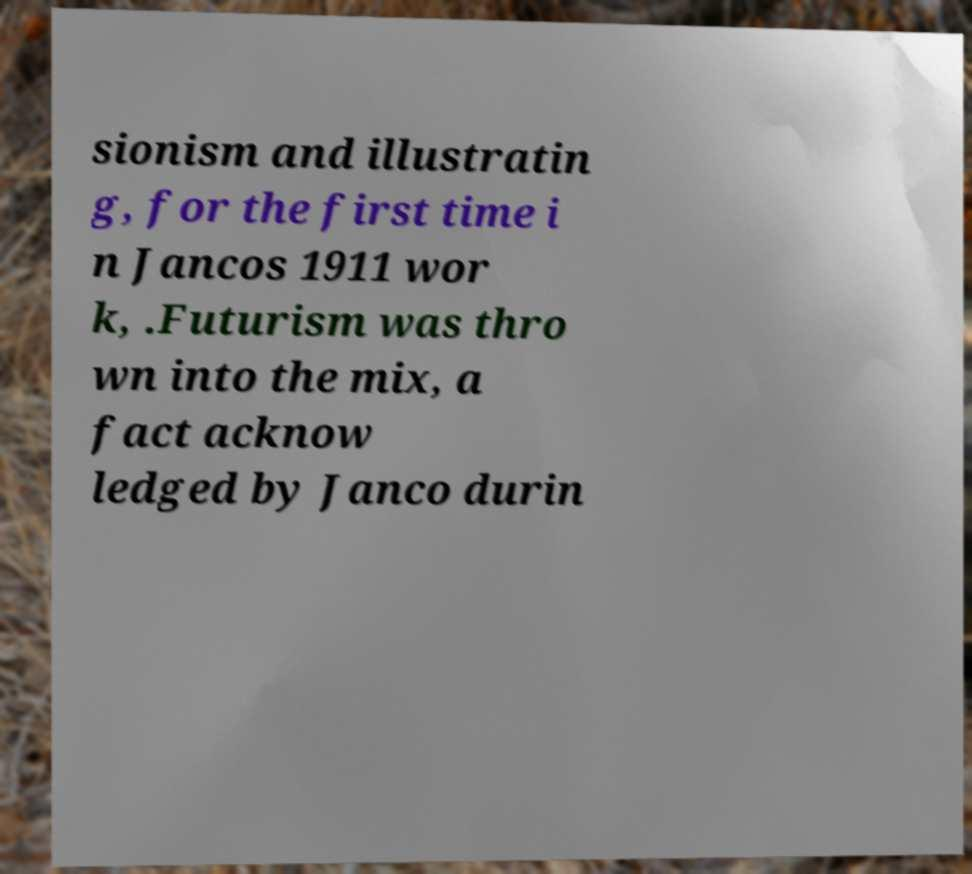Please read and relay the text visible in this image. What does it say? sionism and illustratin g, for the first time i n Jancos 1911 wor k, .Futurism was thro wn into the mix, a fact acknow ledged by Janco durin 